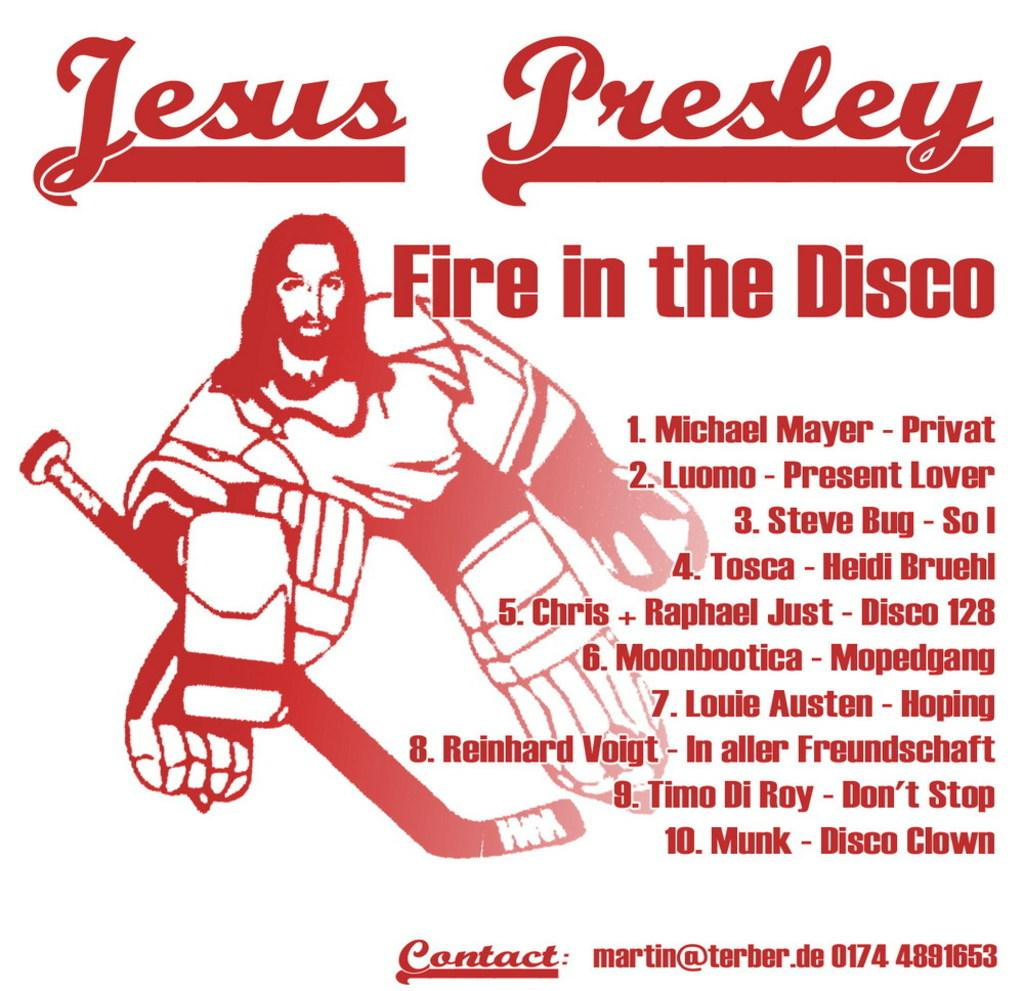<image>
Render a clear and concise summary of the photo. Poster which shows a hockey player and says Fire in the Disco. 